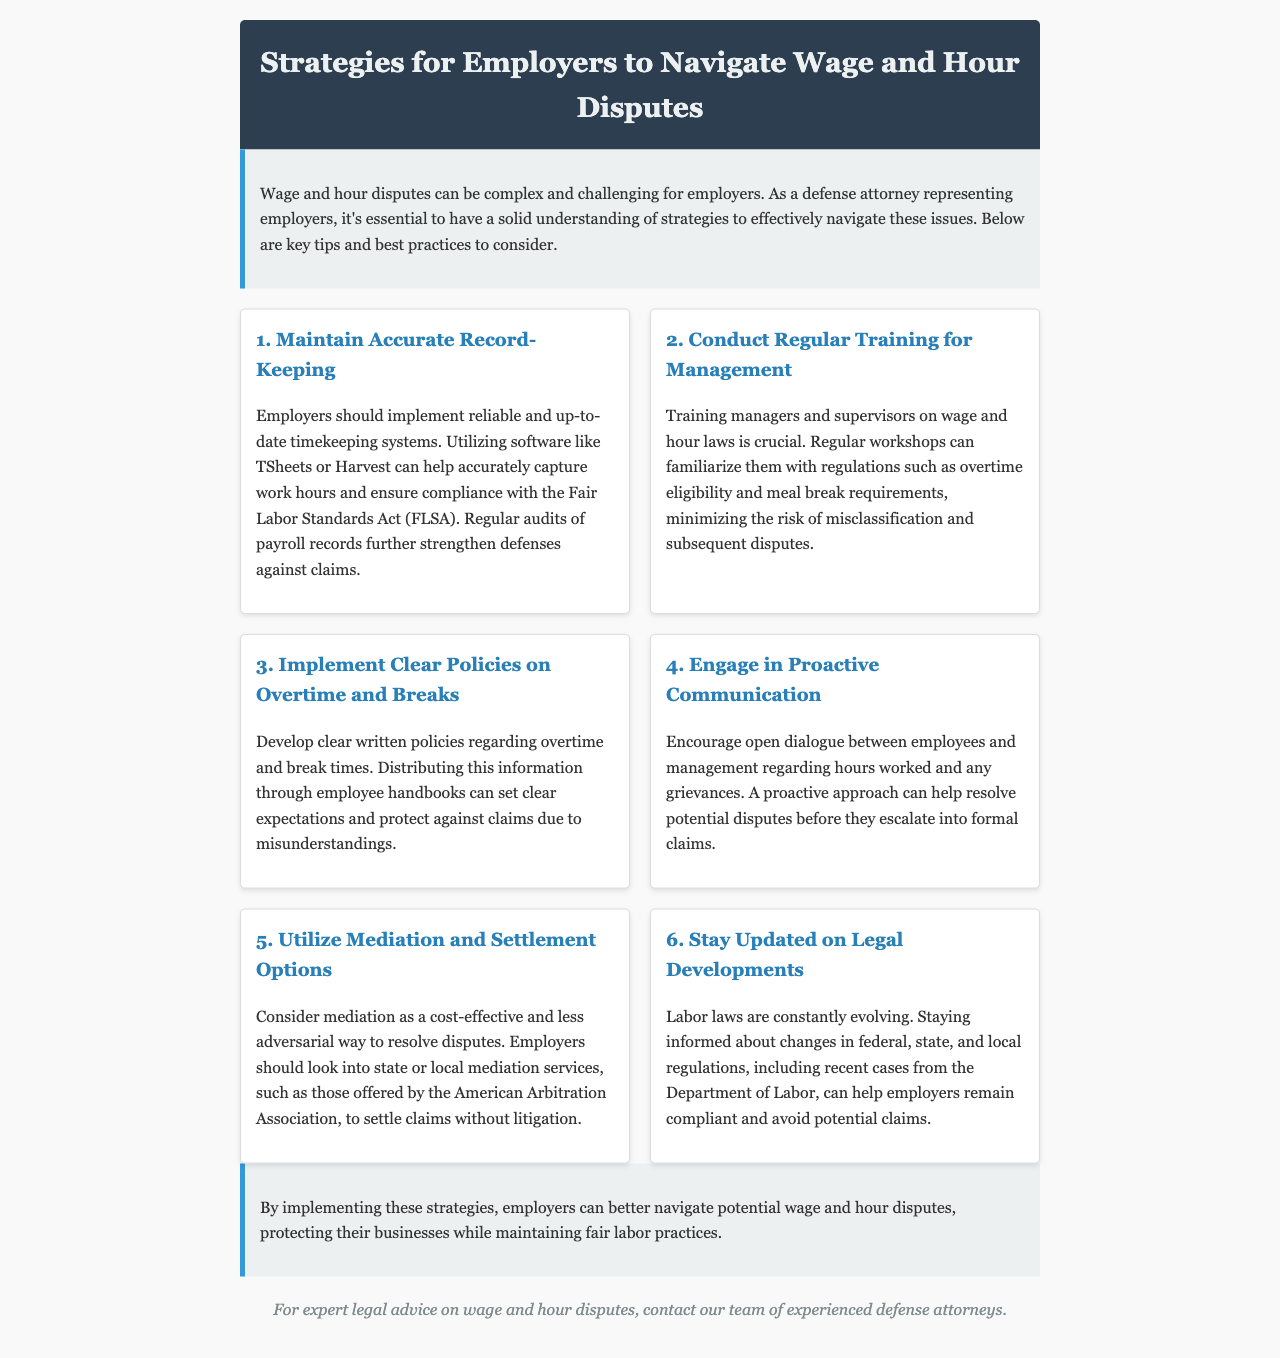What is the title of the newsletter? The title of the newsletter is provided at the top in the header section.
Answer: Strategies for Employers to Navigate Wage and Hour Disputes What is one recommended software for timekeeping? The newsletter lists specific software solutions as part of the strategies for accurate record-keeping.
Answer: TSheets How many strategies are outlined in the document? The document presents a total of six different strategies for employers.
Answer: 6 What is the main purpose of employee training mentioned? The document specifies the critical objective of training for management in relation to wage and hour laws.
Answer: Minimize risk of misclassification Which dispute resolution option is suggested as cost-effective? The newsletter highlights a specific method that employers can consider to resolve disputes without going to court.
Answer: Mediation What key law should employers comply with according to the document? The document mentions a specific federal law relating to wage and hour issues that employers need to adhere to.
Answer: Fair Labor Standards Act 